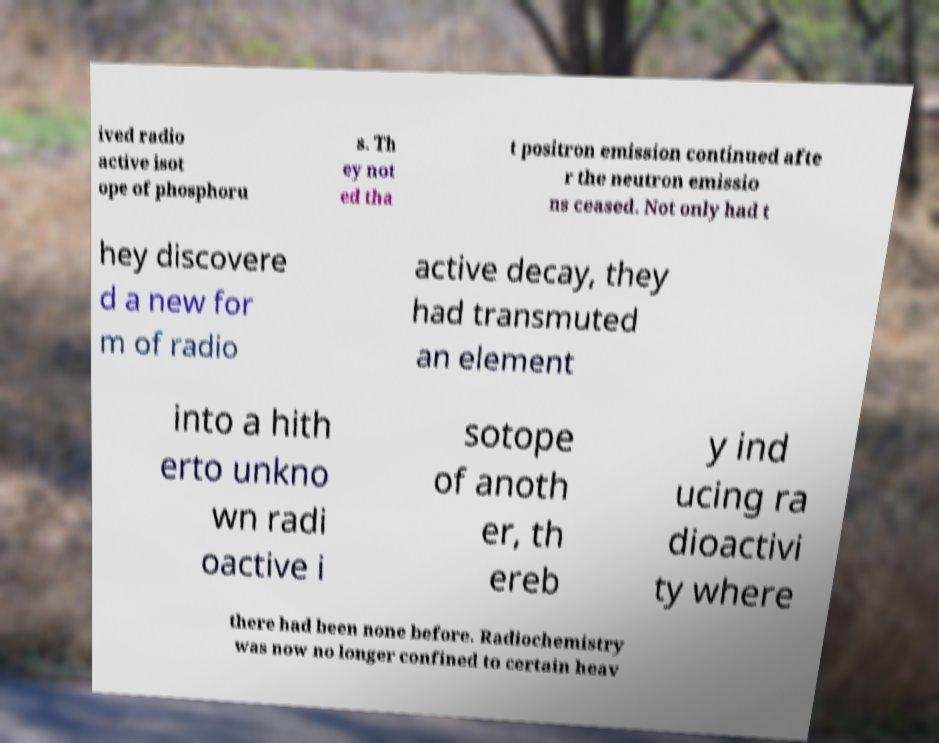What messages or text are displayed in this image? I need them in a readable, typed format. ived radio active isot ope of phosphoru s. Th ey not ed tha t positron emission continued afte r the neutron emissio ns ceased. Not only had t hey discovere d a new for m of radio active decay, they had transmuted an element into a hith erto unkno wn radi oactive i sotope of anoth er, th ereb y ind ucing ra dioactivi ty where there had been none before. Radiochemistry was now no longer confined to certain heav 